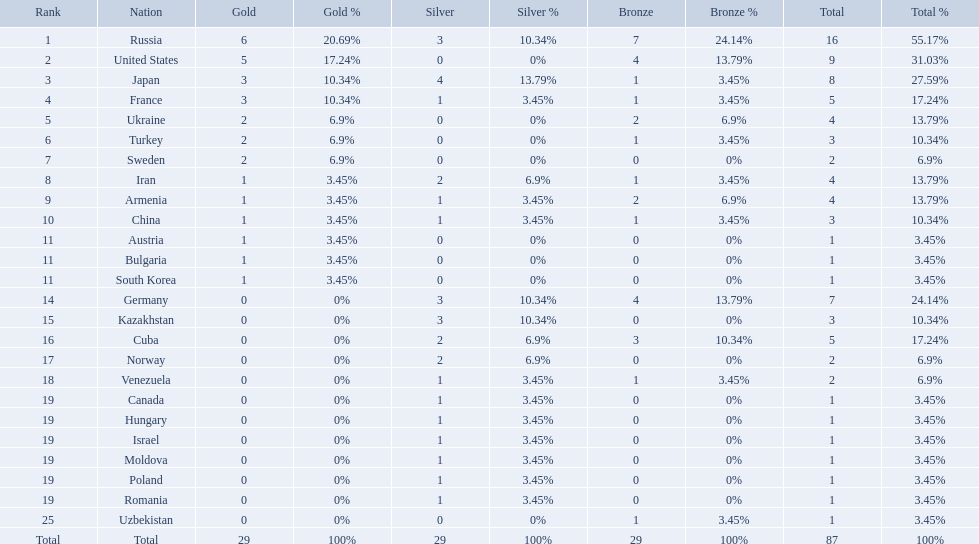Where did iran rank? 8. Where did germany rank? 14. Which of those did make it into the top 10 rank? Germany. Which nations participated in the 1995 world wrestling championships? Russia, United States, Japan, France, Ukraine, Turkey, Sweden, Iran, Armenia, China, Austria, Bulgaria, South Korea, Germany, Kazakhstan, Cuba, Norway, Venezuela, Canada, Hungary, Israel, Moldova, Poland, Romania, Uzbekistan. And between iran and germany, which one placed in the top 10? Germany. How many gold medals did the united states win? 5. Who won more than 5 gold medals? Russia. What were the nations that participated in the 1995 world wrestling championships? Russia, United States, Japan, France, Ukraine, Turkey, Sweden, Iran, Armenia, China, Austria, Bulgaria, South Korea, Germany, Kazakhstan, Cuba, Norway, Venezuela, Canada, Hungary, Israel, Moldova, Poland, Romania, Uzbekistan. How many gold medals did the united states earn in the championship? 5. What amount of medals earner was greater than this value? 6. What country earned these medals? Russia. Which nations have gold medals? Russia, United States, Japan, France, Ukraine, Turkey, Sweden, Iran, Armenia, China, Austria, Bulgaria, South Korea. Of those nations, which have only one gold medal? Iran, Armenia, China, Austria, Bulgaria, South Korea. Of those nations, which has no bronze or silver medals? Austria. 